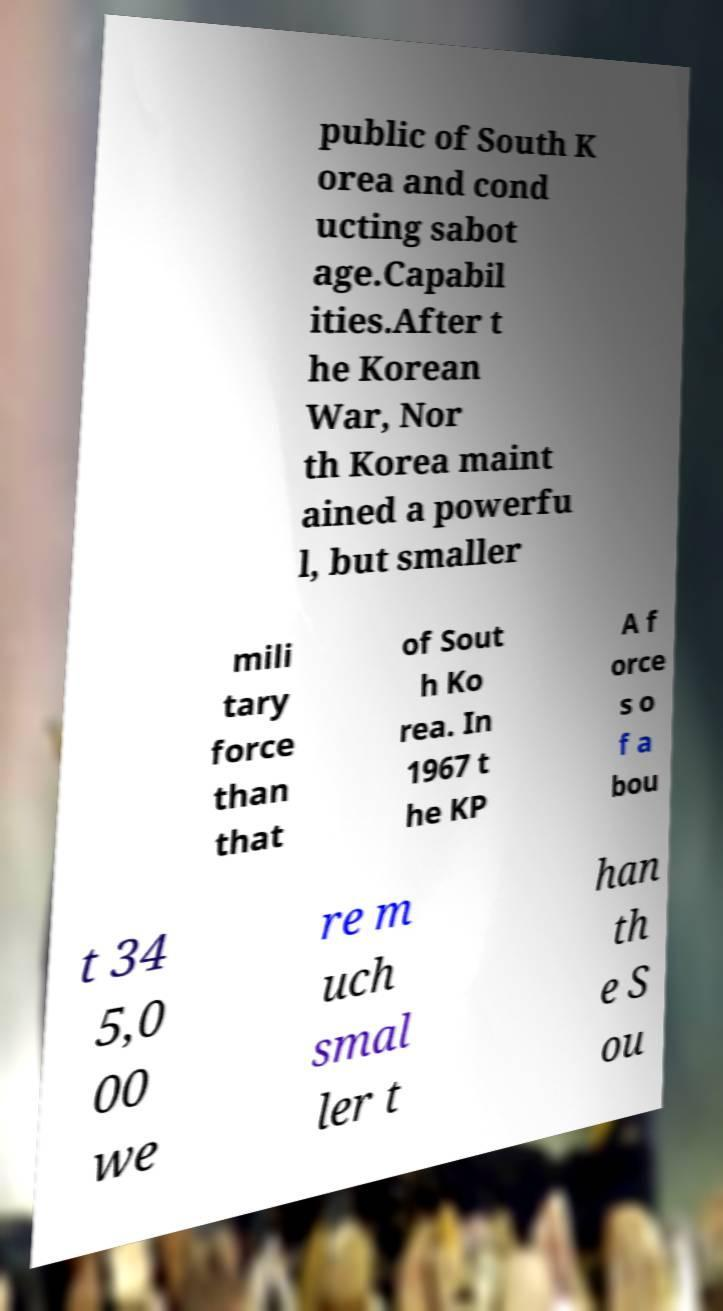There's text embedded in this image that I need extracted. Can you transcribe it verbatim? public of South K orea and cond ucting sabot age.Capabil ities.After t he Korean War, Nor th Korea maint ained a powerfu l, but smaller mili tary force than that of Sout h Ko rea. In 1967 t he KP A f orce s o f a bou t 34 5,0 00 we re m uch smal ler t han th e S ou 